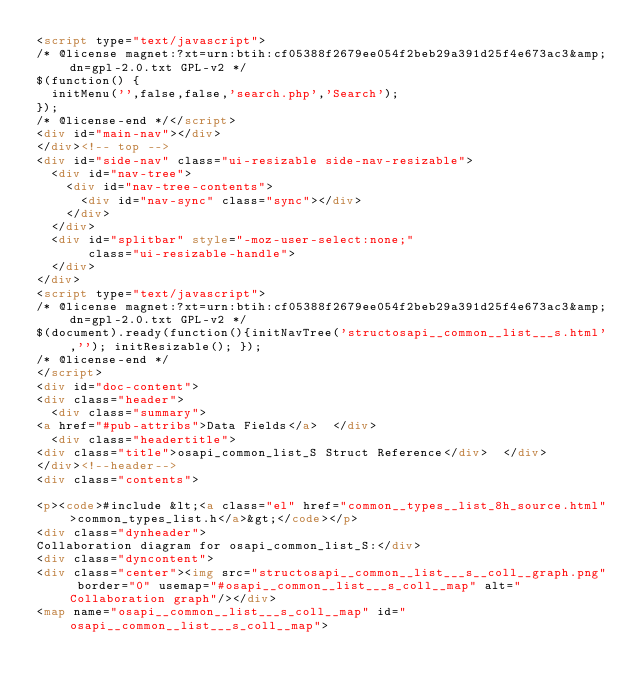Convert code to text. <code><loc_0><loc_0><loc_500><loc_500><_HTML_><script type="text/javascript">
/* @license magnet:?xt=urn:btih:cf05388f2679ee054f2beb29a391d25f4e673ac3&amp;dn=gpl-2.0.txt GPL-v2 */
$(function() {
  initMenu('',false,false,'search.php','Search');
});
/* @license-end */</script>
<div id="main-nav"></div>
</div><!-- top -->
<div id="side-nav" class="ui-resizable side-nav-resizable">
  <div id="nav-tree">
    <div id="nav-tree-contents">
      <div id="nav-sync" class="sync"></div>
    </div>
  </div>
  <div id="splitbar" style="-moz-user-select:none;" 
       class="ui-resizable-handle">
  </div>
</div>
<script type="text/javascript">
/* @license magnet:?xt=urn:btih:cf05388f2679ee054f2beb29a391d25f4e673ac3&amp;dn=gpl-2.0.txt GPL-v2 */
$(document).ready(function(){initNavTree('structosapi__common__list___s.html',''); initResizable(); });
/* @license-end */
</script>
<div id="doc-content">
<div class="header">
  <div class="summary">
<a href="#pub-attribs">Data Fields</a>  </div>
  <div class="headertitle">
<div class="title">osapi_common_list_S Struct Reference</div>  </div>
</div><!--header-->
<div class="contents">

<p><code>#include &lt;<a class="el" href="common__types__list_8h_source.html">common_types_list.h</a>&gt;</code></p>
<div class="dynheader">
Collaboration diagram for osapi_common_list_S:</div>
<div class="dyncontent">
<div class="center"><img src="structosapi__common__list___s__coll__graph.png" border="0" usemap="#osapi__common__list___s_coll__map" alt="Collaboration graph"/></div>
<map name="osapi__common__list___s_coll__map" id="osapi__common__list___s_coll__map"></code> 